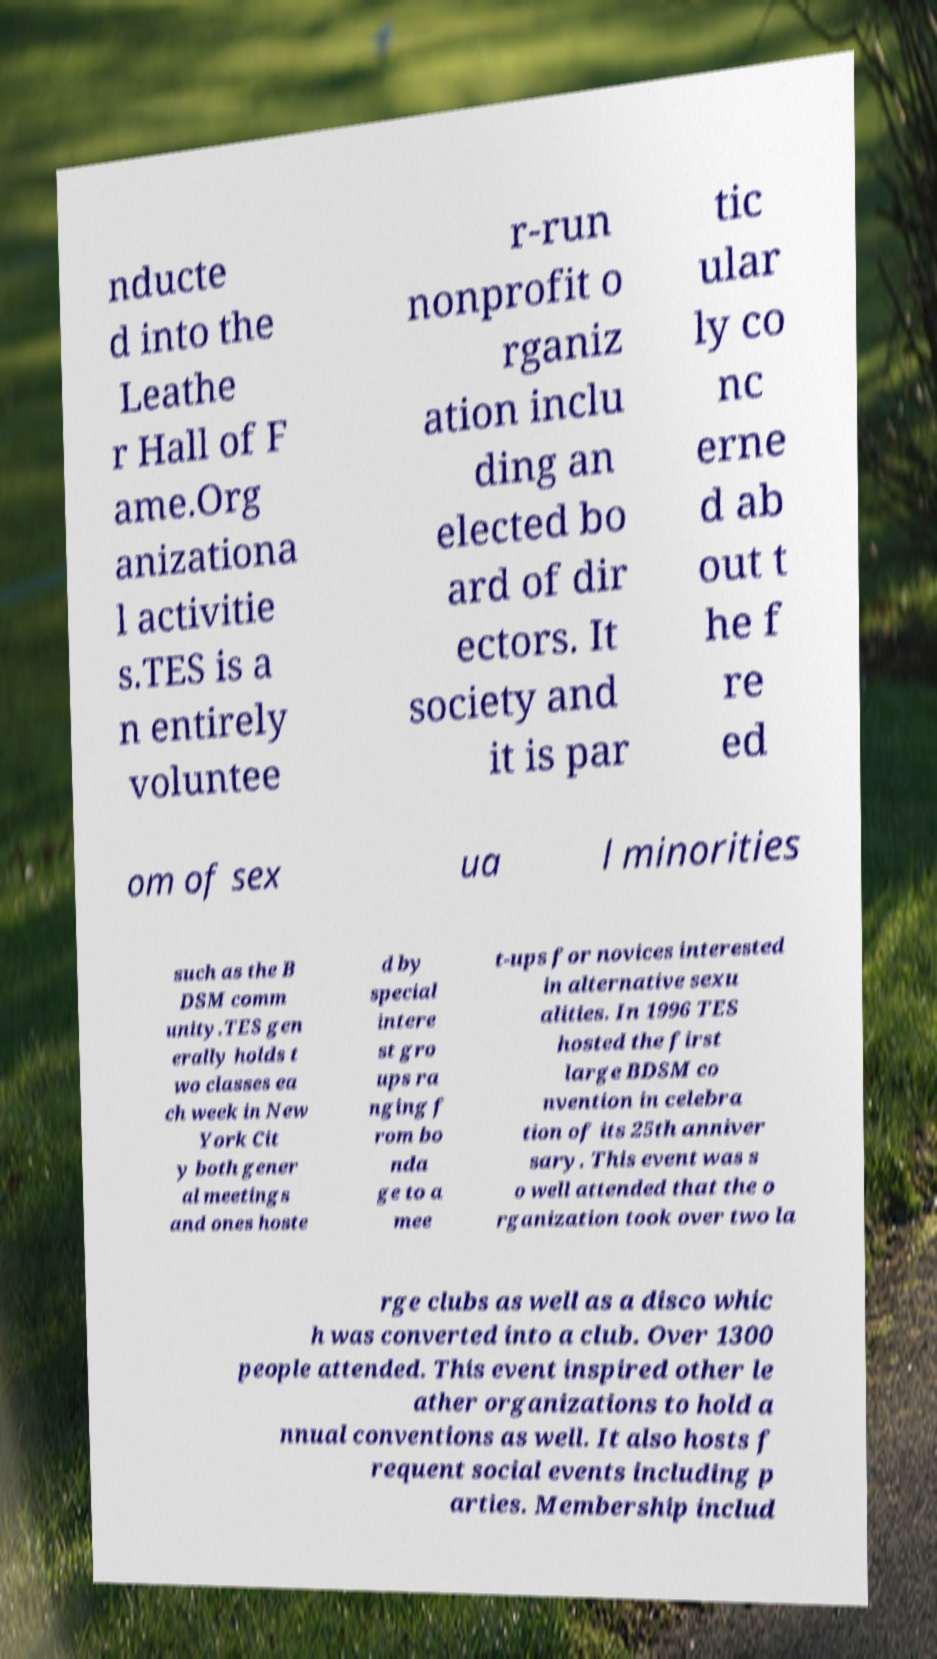Could you extract and type out the text from this image? nducte d into the Leathe r Hall of F ame.Org anizationa l activitie s.TES is a n entirely voluntee r-run nonprofit o rganiz ation inclu ding an elected bo ard of dir ectors. It society and it is par tic ular ly co nc erne d ab out t he f re ed om of sex ua l minorities such as the B DSM comm unity.TES gen erally holds t wo classes ea ch week in New York Cit y both gener al meetings and ones hoste d by special intere st gro ups ra nging f rom bo nda ge to a mee t-ups for novices interested in alternative sexu alities. In 1996 TES hosted the first large BDSM co nvention in celebra tion of its 25th anniver sary. This event was s o well attended that the o rganization took over two la rge clubs as well as a disco whic h was converted into a club. Over 1300 people attended. This event inspired other le ather organizations to hold a nnual conventions as well. It also hosts f requent social events including p arties. Membership includ 